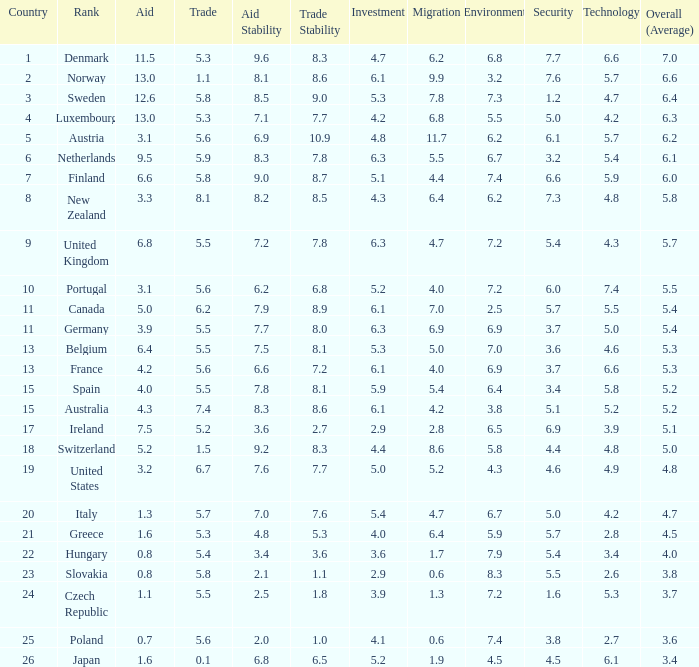What is the environment rating of the country with an overall average rating of 4.7? 6.7. 